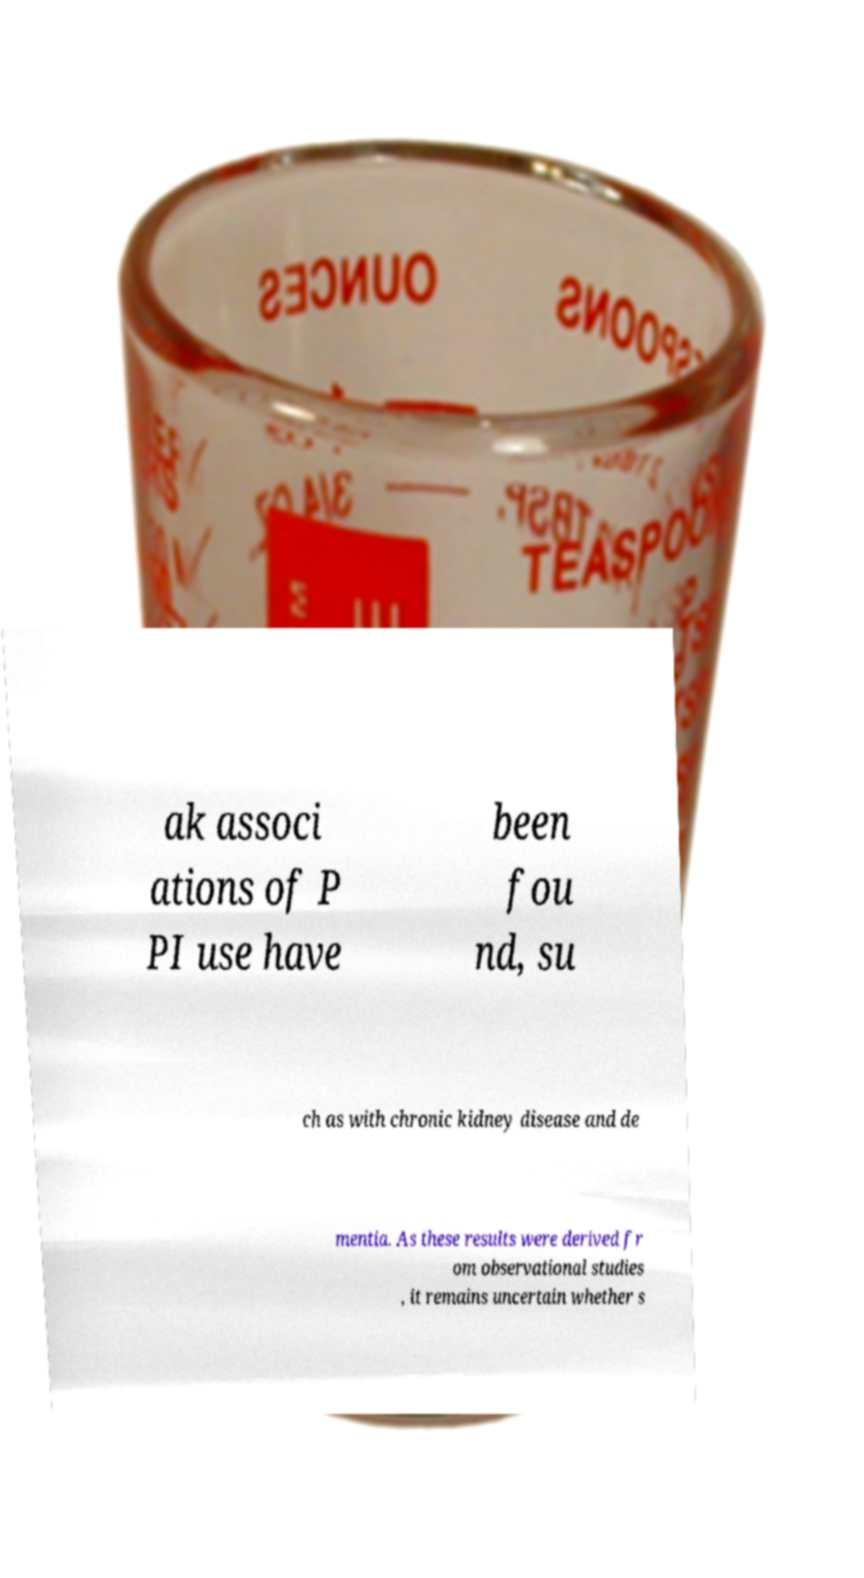Can you read and provide the text displayed in the image?This photo seems to have some interesting text. Can you extract and type it out for me? ak associ ations of P PI use have been fou nd, su ch as with chronic kidney disease and de mentia. As these results were derived fr om observational studies , it remains uncertain whether s 